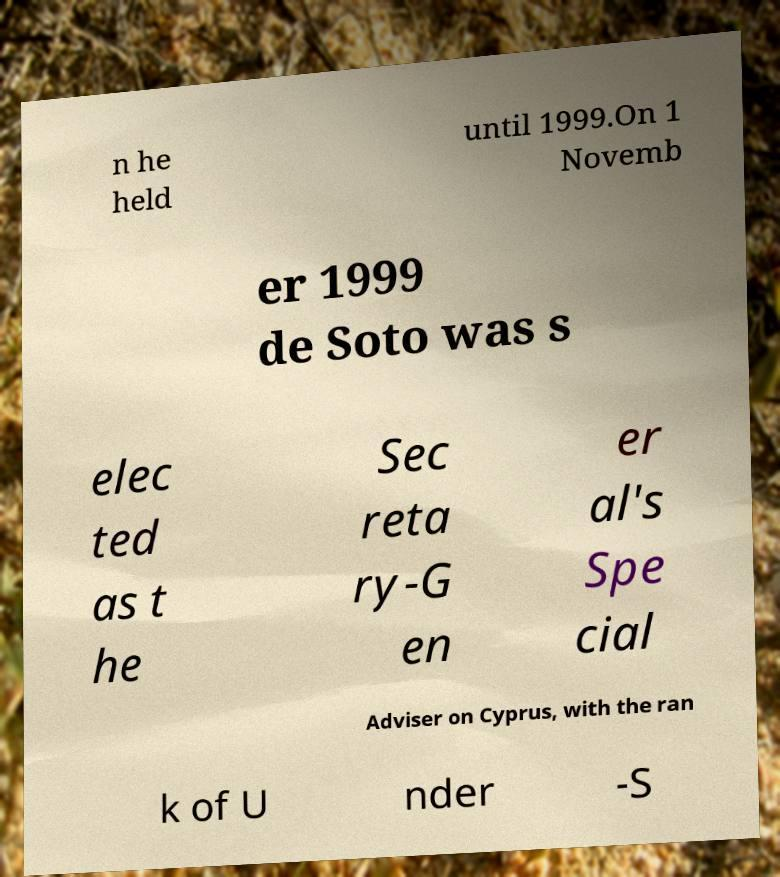There's text embedded in this image that I need extracted. Can you transcribe it verbatim? n he held until 1999.On 1 Novemb er 1999 de Soto was s elec ted as t he Sec reta ry-G en er al's Spe cial Adviser on Cyprus, with the ran k of U nder -S 